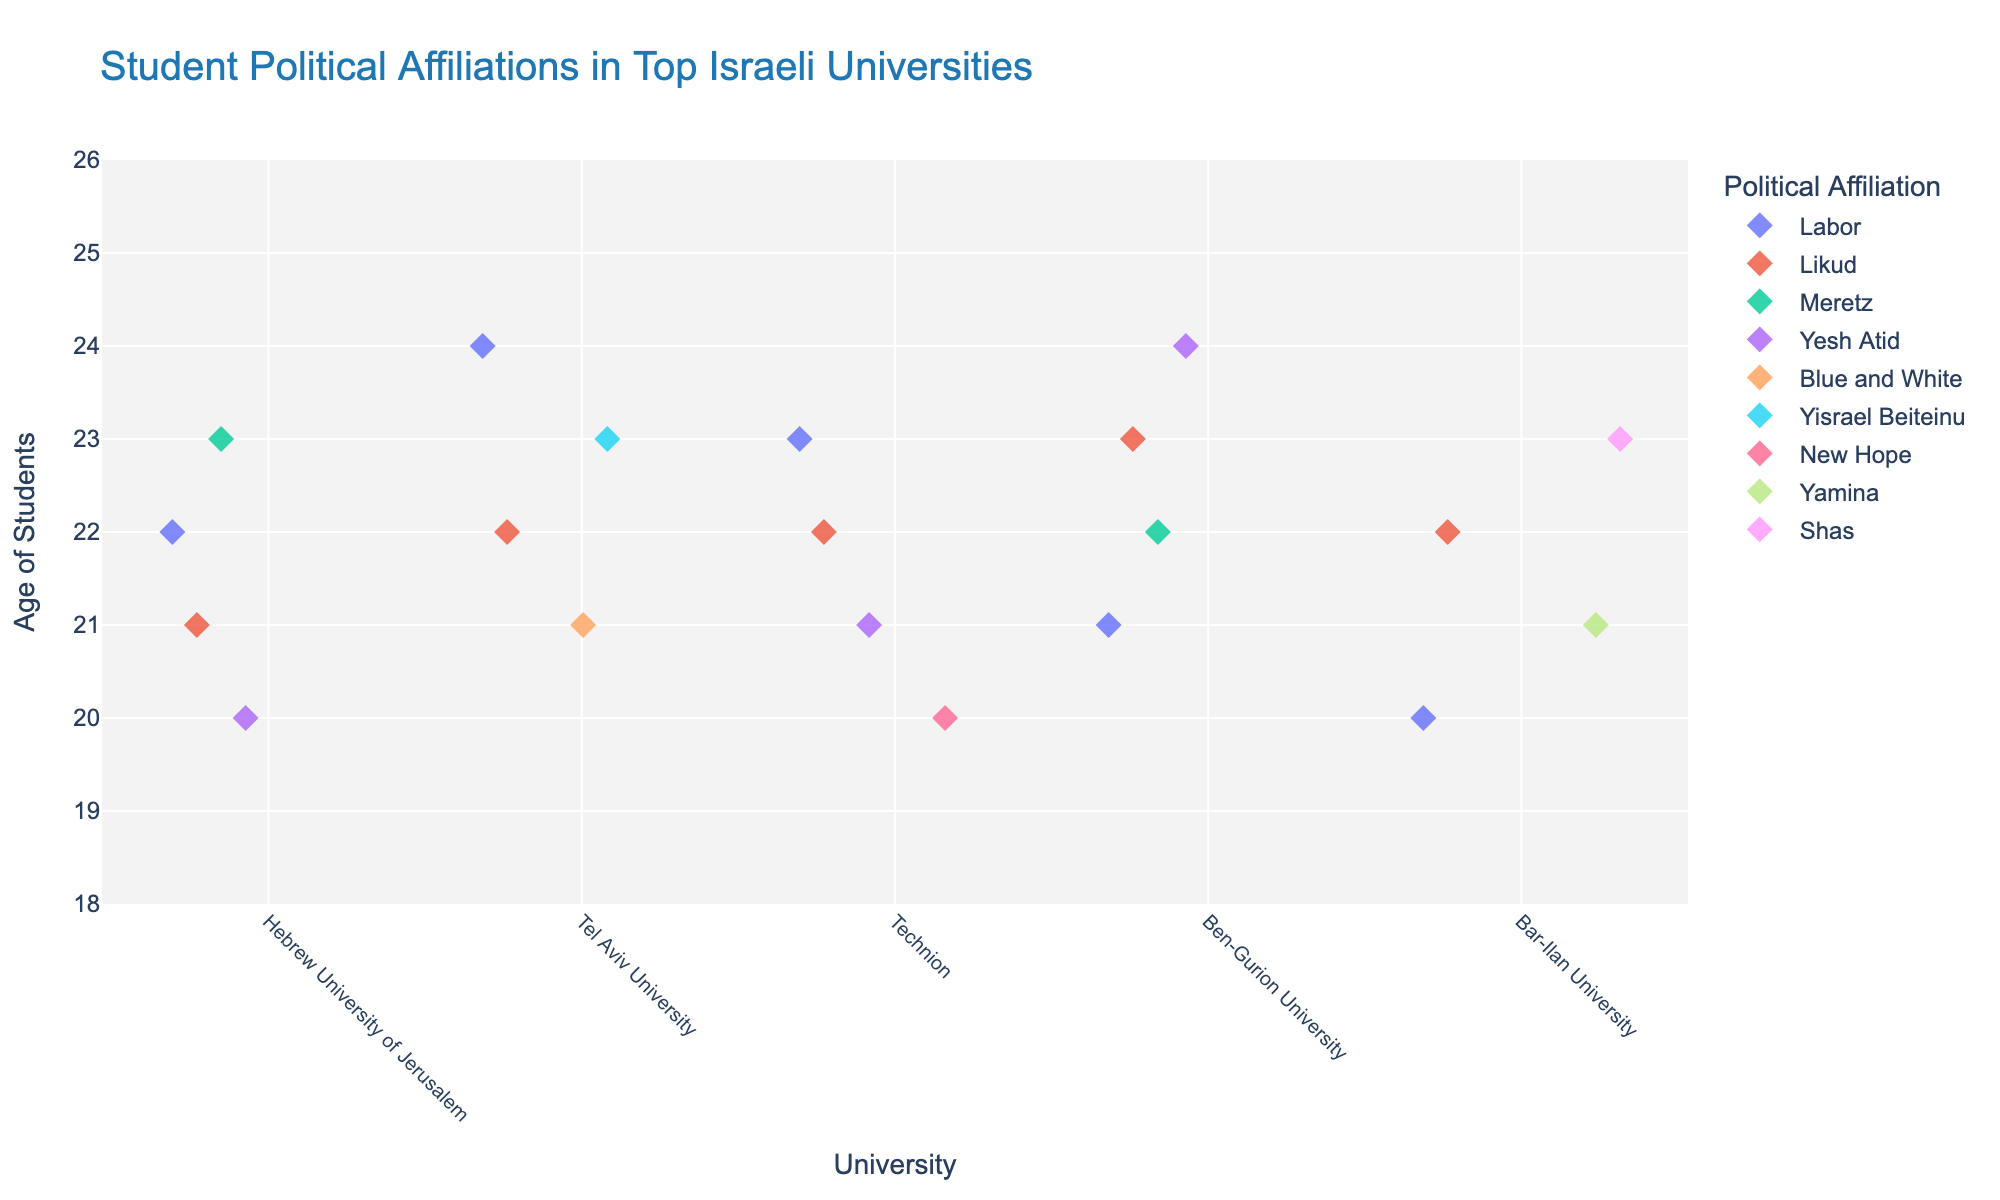How many universities are represented in the plot? To determine the number of universities represented, count the unique categories on the x-axis labeled "University." The universities are Hebrew University of Jerusalem, Tel Aviv University, Technion, Ben-Gurion University, and Bar-Ilan University.
Answer: 5 Which university has the oldest student represented in the plot? Identify the student with the highest age value on the y-axis and find the corresponding university on the x-axis. The oldest student, aged 24, is from both Tel Aviv University and Ben-Gurion University.
Answer: Tel Aviv University, Ben-Gurion University What is the most common political affiliation among students at Bar-Ilan University? Observe the colors and corresponding political affiliations of the markers at the Bar-Ilan University category on the x-axis. Count the number of markers for each political affiliation. The affiliations are Likud, Yamina, and Shas, with Likud being the most frequent.
Answer: Likud Which political affiliation has students represented at all five universities? For each political affiliation, check if there is at least one marker in each of the five university categories on the x-axis. Labor is the only affiliation with representation in all five universities.
Answer: Labor How does the age distribution of students in Labor compare across the universities? Compare the vertical positions (y-axis) of markers colored according to the Labor affiliation across the different university categories on the x-axis. The age distribution of Labor students ranges from 20 to 24 years across all universities.
Answer: 20-24 years What is the average age of students affiliated with Likud at Technion? Identify the markers colored for Likud within the Technion category on the x-axis and note their positions on the y-axis (al) representing age. The ages are 22. The average of these values is the same as 22.0 years.
Answer: 22.0 years Are there any universities where political affiliations are more varied compared to others? Observe the number of different colors (representing political affiliations) in each university category on the x-axis. Compare the variety across universities. Hebrew University of Jerusalem and Bar-Ilan University both show a diverse range of political affiliations.
Answer: Hebrew University of Jerusalem, Bar-Ilan University 